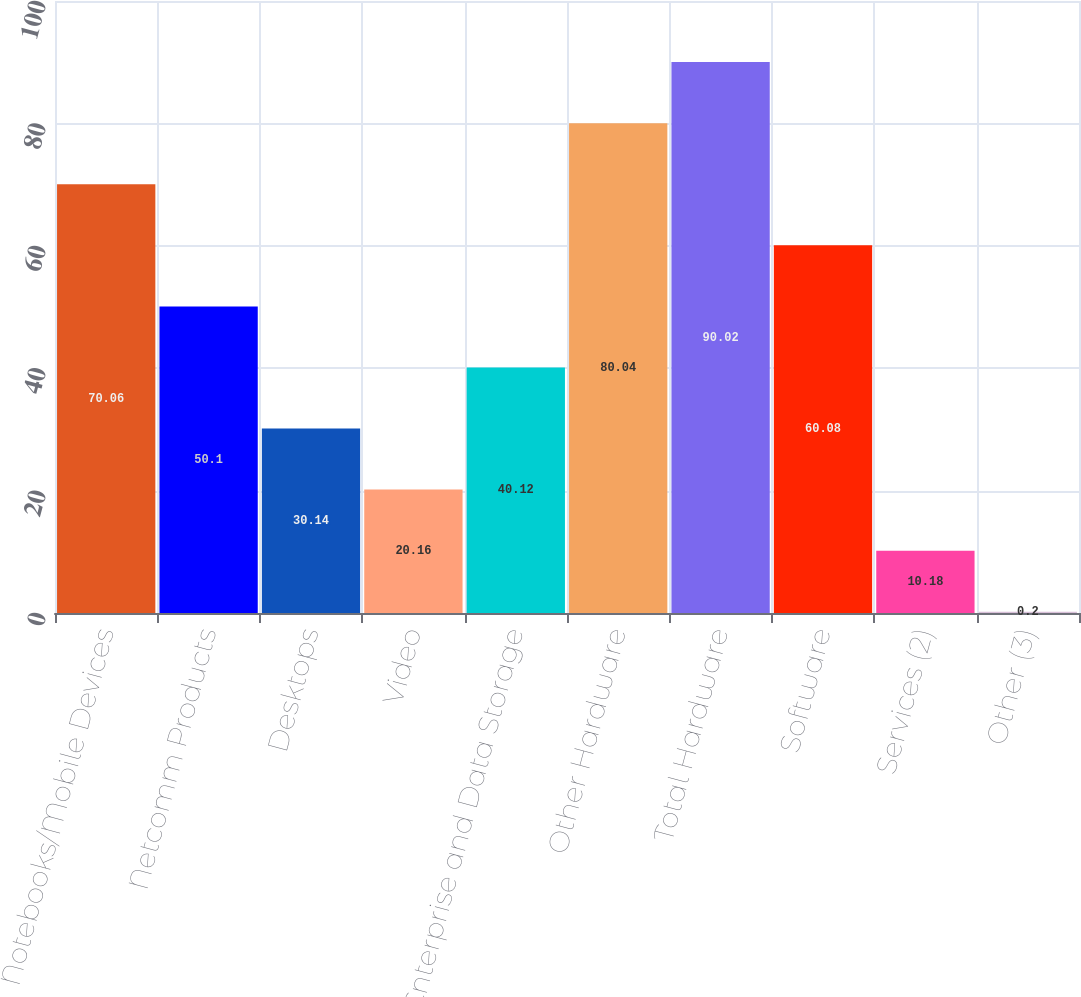Convert chart to OTSL. <chart><loc_0><loc_0><loc_500><loc_500><bar_chart><fcel>Notebooks/Mobile Devices<fcel>Netcomm Products<fcel>Desktops<fcel>Video<fcel>Enterprise and Data Storage<fcel>Other Hardware<fcel>Total Hardware<fcel>Software<fcel>Services (2)<fcel>Other (3)<nl><fcel>70.06<fcel>50.1<fcel>30.14<fcel>20.16<fcel>40.12<fcel>80.04<fcel>90.02<fcel>60.08<fcel>10.18<fcel>0.2<nl></chart> 